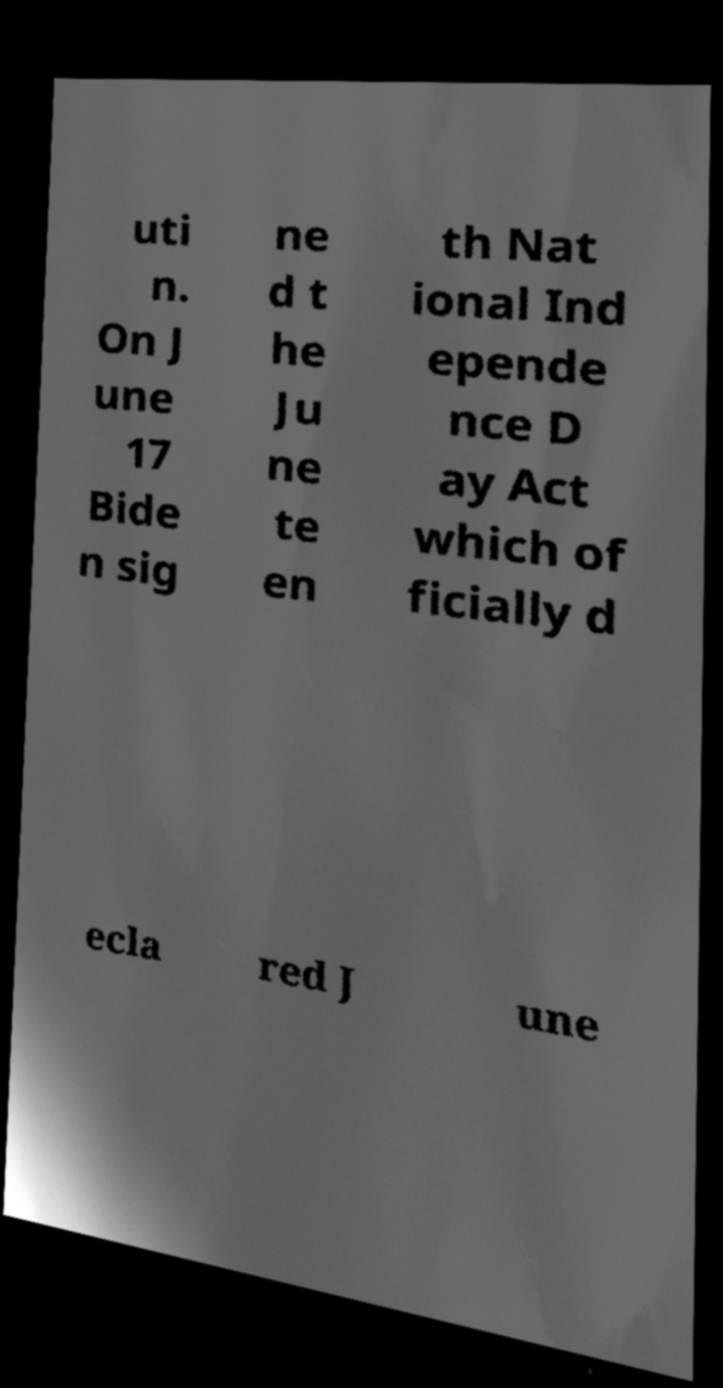Please identify and transcribe the text found in this image. uti n. On J une 17 Bide n sig ne d t he Ju ne te en th Nat ional Ind epende nce D ay Act which of ficially d ecla red J une 